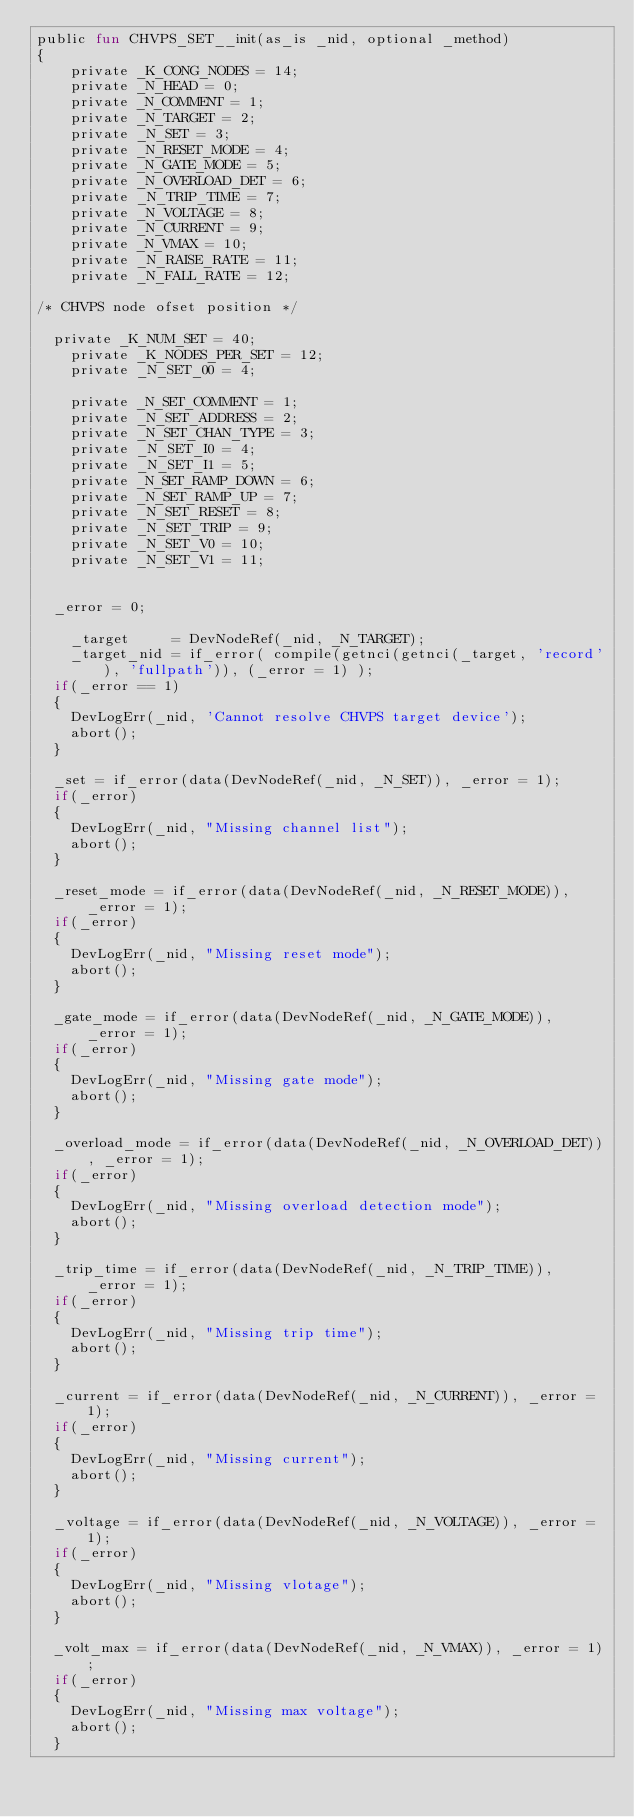<code> <loc_0><loc_0><loc_500><loc_500><_SML_>public fun CHVPS_SET__init(as_is _nid, optional _method)
{
    private _K_CONG_NODES = 14;
    private _N_HEAD = 0;
    private _N_COMMENT = 1;
    private _N_TARGET = 2;
    private _N_SET = 3;
    private _N_RESET_MODE = 4;
    private _N_GATE_MODE = 5;
    private _N_OVERLOAD_DET = 6;
    private _N_TRIP_TIME = 7;
    private _N_VOLTAGE = 8;
    private _N_CURRENT = 9;
    private _N_VMAX = 10;
    private _N_RAISE_RATE = 11;
    private _N_FALL_RATE = 12;

/* CHVPS node ofset position */

	private _K_NUM_SET = 40;
    private _K_NODES_PER_SET = 12;
    private _N_SET_00 = 4;

    private _N_SET_COMMENT = 1;
    private _N_SET_ADDRESS = 2;
    private _N_SET_CHAN_TYPE = 3;
    private _N_SET_I0 = 4;
    private _N_SET_I1 = 5;
    private _N_SET_RAMP_DOWN = 6;
    private _N_SET_RAMP_UP = 7;
    private _N_SET_RESET = 8;
    private _N_SET_TRIP = 9;
    private _N_SET_V0 = 10;
    private _N_SET_V1 = 11;


	_error = 0;

    _target     = DevNodeRef(_nid, _N_TARGET);
    _target_nid = if_error( compile(getnci(getnci(_target, 'record'), 'fullpath')), (_error = 1) );
	if(_error == 1)
	{
		DevLogErr(_nid, 'Cannot resolve CHVPS target device');
		abort();
	}

	_set = if_error(data(DevNodeRef(_nid, _N_SET)), _error = 1);
	if(_error)
	{
		DevLogErr(_nid, "Missing channel list"); 
		abort();
	}

	_reset_mode = if_error(data(DevNodeRef(_nid, _N_RESET_MODE)), _error = 1);
	if(_error)
	{
		DevLogErr(_nid, "Missing reset mode"); 
		abort();
	}

	_gate_mode = if_error(data(DevNodeRef(_nid, _N_GATE_MODE)), _error = 1);
	if(_error)
	{
		DevLogErr(_nid, "Missing gate mode"); 
		abort();
	}

	_overload_mode = if_error(data(DevNodeRef(_nid, _N_OVERLOAD_DET)), _error = 1);
	if(_error)
	{
		DevLogErr(_nid, "Missing overload detection mode"); 
		abort();
	}

	_trip_time = if_error(data(DevNodeRef(_nid, _N_TRIP_TIME)), _error = 1);
	if(_error)
	{
		DevLogErr(_nid, "Missing trip time"); 
		abort();
	}

	_current = if_error(data(DevNodeRef(_nid, _N_CURRENT)), _error = 1);
	if(_error)
	{
		DevLogErr(_nid, "Missing current"); 
		abort();
	}

	_voltage = if_error(data(DevNodeRef(_nid, _N_VOLTAGE)), _error = 1);
	if(_error)
	{
		DevLogErr(_nid, "Missing vlotage"); 
		abort();
	}

	_volt_max = if_error(data(DevNodeRef(_nid, _N_VMAX)), _error = 1);
	if(_error)
	{
		DevLogErr(_nid, "Missing max voltage"); 
		abort();
	}
</code> 